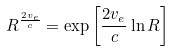<formula> <loc_0><loc_0><loc_500><loc_500>R ^ { \frac { 2 v _ { e } } { c } } = \exp \left [ { \frac { 2 v _ { e } } { c } } \ln R \right ]</formula> 